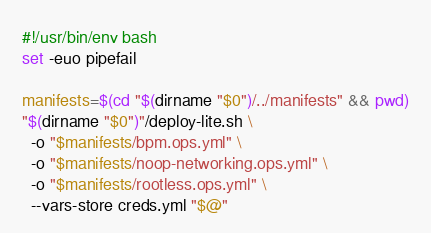Convert code to text. <code><loc_0><loc_0><loc_500><loc_500><_Bash_>#!/usr/bin/env bash
set -euo pipefail

manifests=$(cd "$(dirname "$0")/../manifests" && pwd)
"$(dirname "$0")"/deploy-lite.sh \
  -o "$manifests/bpm.ops.yml" \
  -o "$manifests/noop-networking.ops.yml" \
  -o "$manifests/rootless.ops.yml" \
  --vars-store creds.yml "$@"
</code> 